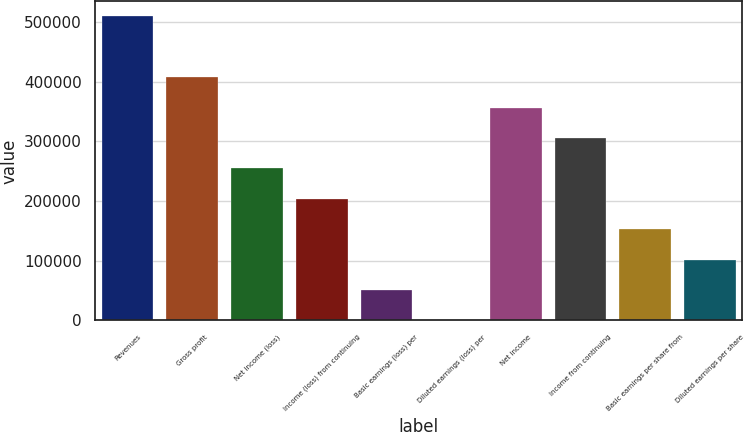Convert chart. <chart><loc_0><loc_0><loc_500><loc_500><bar_chart><fcel>Revenues<fcel>Gross profit<fcel>Net income (loss)<fcel>Income (loss) from continuing<fcel>Basic earnings (loss) per<fcel>Diluted earnings (loss) per<fcel>Net income<fcel>Income from continuing<fcel>Basic earnings per share from<fcel>Diluted earnings per share<nl><fcel>509115<fcel>407292<fcel>254558<fcel>203646<fcel>50911.6<fcel>0.14<fcel>356381<fcel>305469<fcel>152735<fcel>101823<nl></chart> 